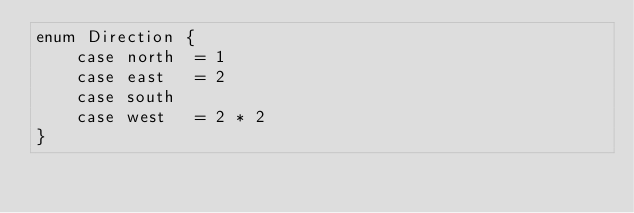Convert code to text. <code><loc_0><loc_0><loc_500><loc_500><_XML_>enum Direction {
    case north  = 1
    case east   = 2
    case south
    case west   = 2 * 2
}</code> 